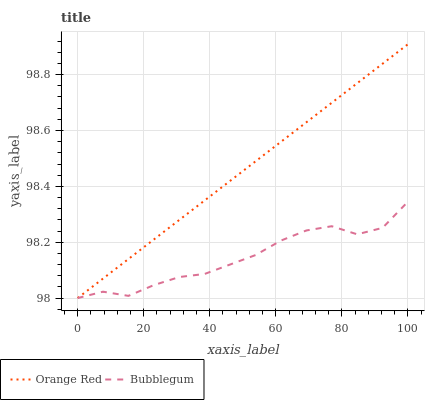Does Bubblegum have the maximum area under the curve?
Answer yes or no. No. Is Bubblegum the smoothest?
Answer yes or no. No. Does Bubblegum have the highest value?
Answer yes or no. No. 